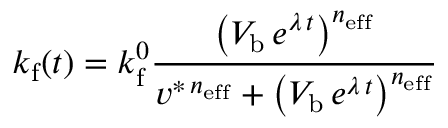Convert formula to latex. <formula><loc_0><loc_0><loc_500><loc_500>k _ { f } ( t ) = k _ { f } ^ { 0 } \frac { \left ( V _ { b } \, e ^ { \lambda \, t } \right ) ^ { n _ { e f f } } } { v ^ { \ast \, n _ { e f f } } + \left ( V _ { b } \, e ^ { \lambda \, t } \right ) ^ { n _ { e f f } } }</formula> 